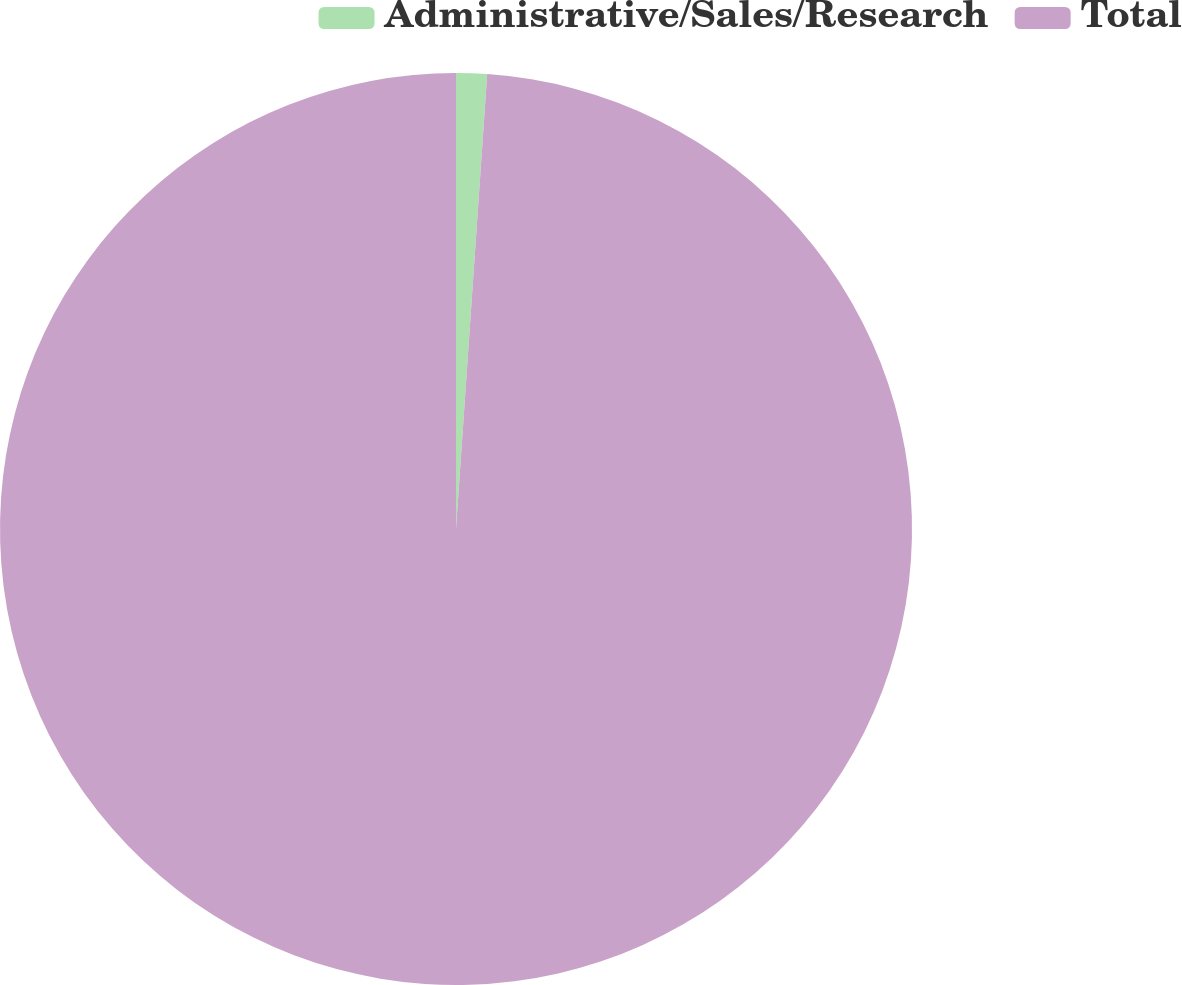Convert chart. <chart><loc_0><loc_0><loc_500><loc_500><pie_chart><fcel>Administrative/Sales/Research<fcel>Total<nl><fcel>1.09%<fcel>98.91%<nl></chart> 